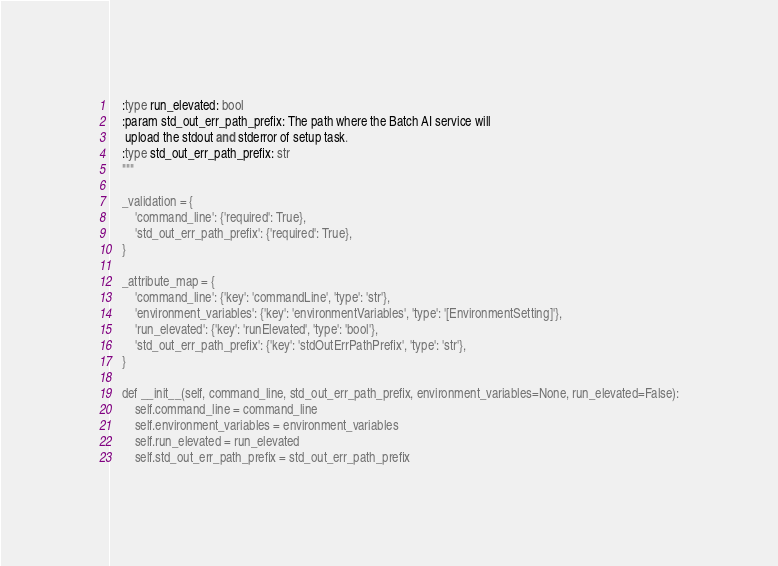Convert code to text. <code><loc_0><loc_0><loc_500><loc_500><_Python_>    :type run_elevated: bool
    :param std_out_err_path_prefix: The path where the Batch AI service will
     upload the stdout and stderror of setup task.
    :type std_out_err_path_prefix: str
    """

    _validation = {
        'command_line': {'required': True},
        'std_out_err_path_prefix': {'required': True},
    }

    _attribute_map = {
        'command_line': {'key': 'commandLine', 'type': 'str'},
        'environment_variables': {'key': 'environmentVariables', 'type': '[EnvironmentSetting]'},
        'run_elevated': {'key': 'runElevated', 'type': 'bool'},
        'std_out_err_path_prefix': {'key': 'stdOutErrPathPrefix', 'type': 'str'},
    }

    def __init__(self, command_line, std_out_err_path_prefix, environment_variables=None, run_elevated=False):
        self.command_line = command_line
        self.environment_variables = environment_variables
        self.run_elevated = run_elevated
        self.std_out_err_path_prefix = std_out_err_path_prefix
</code> 